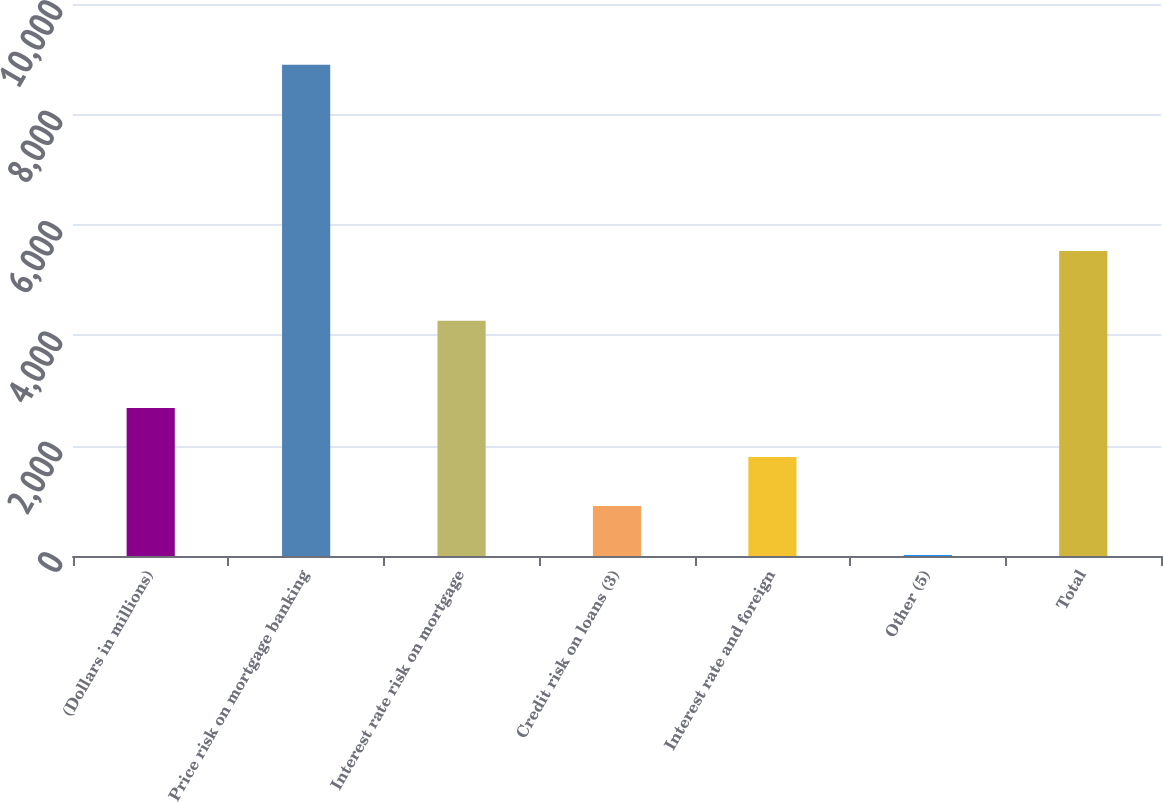<chart> <loc_0><loc_0><loc_500><loc_500><bar_chart><fcel>(Dollars in millions)<fcel>Price risk on mortgage banking<fcel>Interest rate risk on mortgage<fcel>Credit risk on loans (3)<fcel>Interest rate and foreign<fcel>Other (5)<fcel>Total<nl><fcel>2680.6<fcel>8898<fcel>4264<fcel>904.2<fcel>1792.4<fcel>16<fcel>5524<nl></chart> 